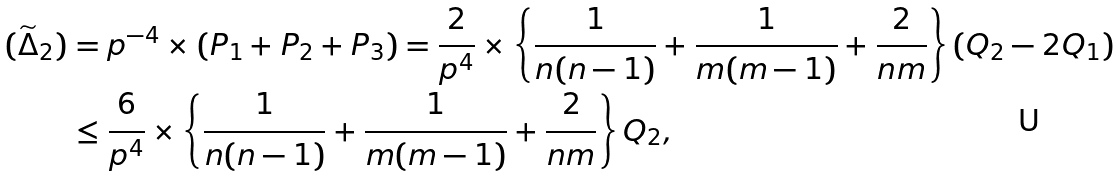Convert formula to latex. <formula><loc_0><loc_0><loc_500><loc_500>( \widetilde { \Delta } _ { 2 } ) & = p ^ { - 4 } \times ( P _ { 1 } + P _ { 2 } + P _ { 3 } ) = \frac { 2 } { p ^ { 4 } } \times \left \{ \frac { 1 } { n ( n - 1 ) } + \frac { 1 } { m ( m - 1 ) } + \frac { 2 } { n m } \right \} ( Q _ { 2 } - 2 Q _ { 1 } ) \\ & \leq \frac { 6 } { p ^ { 4 } } \times \left \{ \frac { 1 } { n ( n - 1 ) } + \frac { 1 } { m ( m - 1 ) } + \frac { 2 } { n m } \right \} Q _ { 2 } ,</formula> 